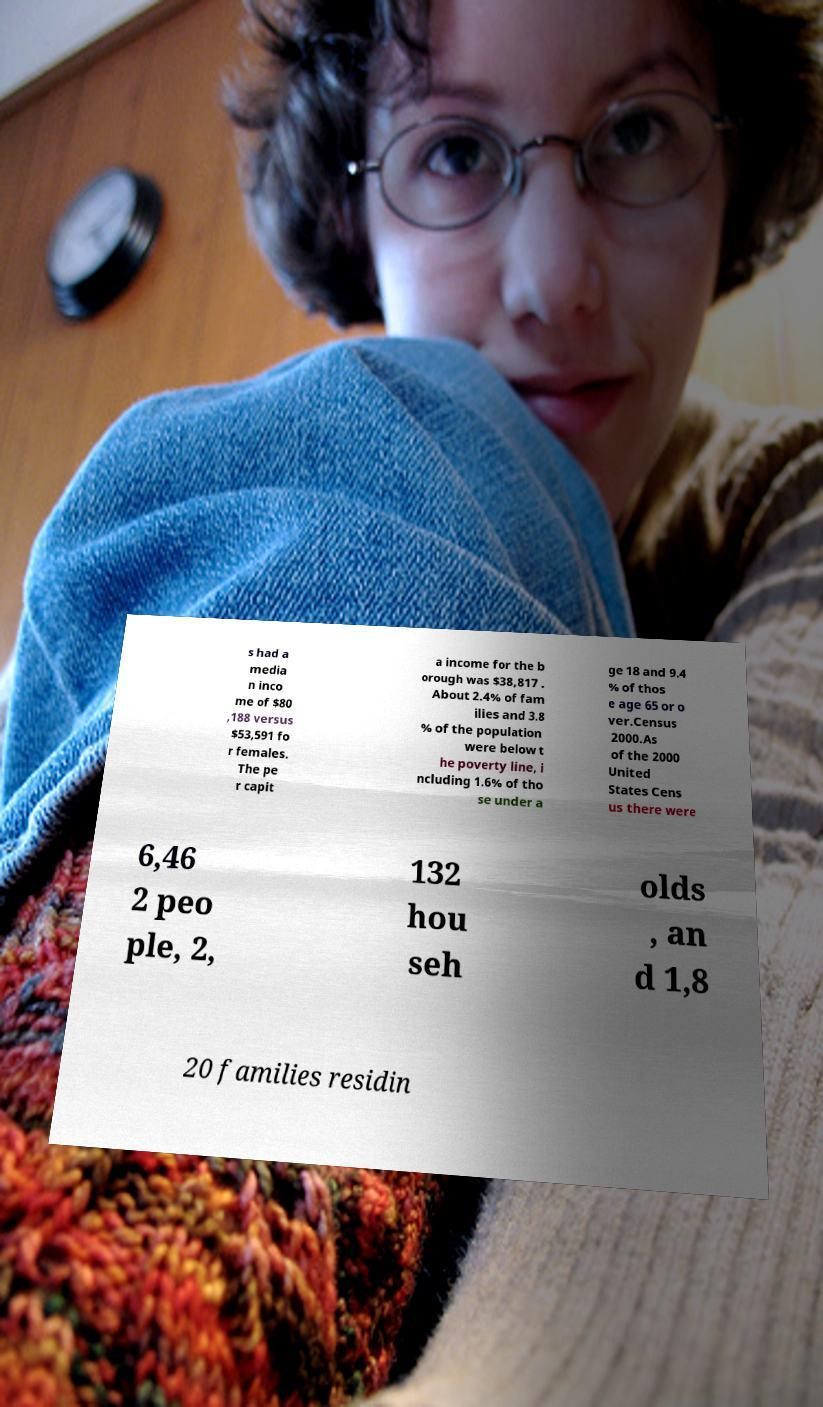What messages or text are displayed in this image? I need them in a readable, typed format. s had a media n inco me of $80 ,188 versus $53,591 fo r females. The pe r capit a income for the b orough was $38,817 . About 2.4% of fam ilies and 3.8 % of the population were below t he poverty line, i ncluding 1.6% of tho se under a ge 18 and 9.4 % of thos e age 65 or o ver.Census 2000.As of the 2000 United States Cens us there were 6,46 2 peo ple, 2, 132 hou seh olds , an d 1,8 20 families residin 